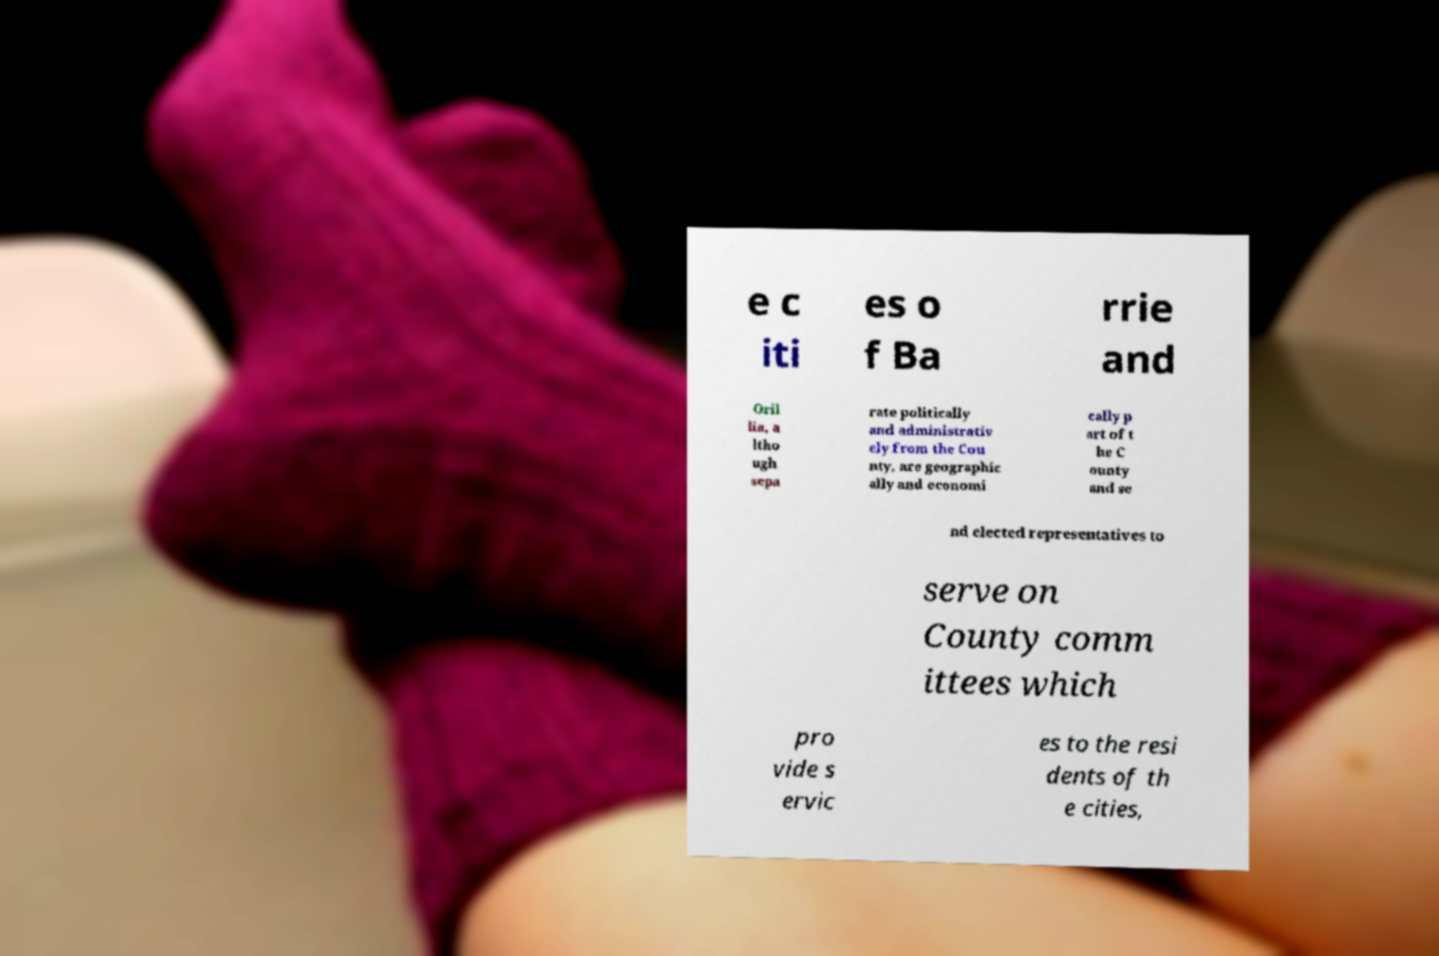Can you read and provide the text displayed in the image?This photo seems to have some interesting text. Can you extract and type it out for me? e c iti es o f Ba rrie and Oril lia, a ltho ugh sepa rate politically and administrativ ely from the Cou nty, are geographic ally and economi cally p art of t he C ounty and se nd elected representatives to serve on County comm ittees which pro vide s ervic es to the resi dents of th e cities, 